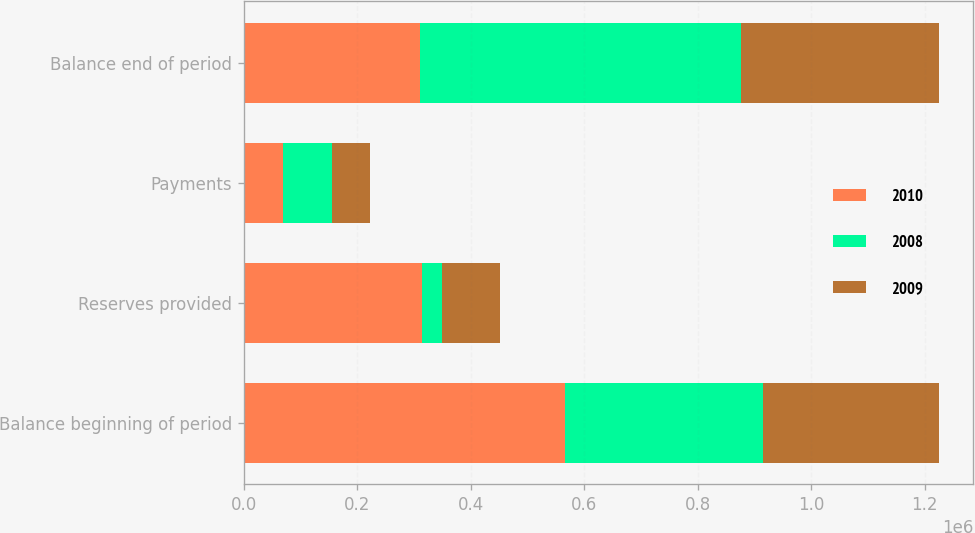Convert chart. <chart><loc_0><loc_0><loc_500><loc_500><stacked_bar_chart><ecel><fcel>Balance beginning of period<fcel>Reserves provided<fcel>Payments<fcel>Balance end of period<nl><fcel>2010<fcel>566693<fcel>313606<fcel>68972<fcel>309900<nl><fcel>2008<fcel>347631<fcel>34939<fcel>86948<fcel>566693<nl><fcel>2009<fcel>309900<fcel>103505<fcel>65774<fcel>347631<nl></chart> 